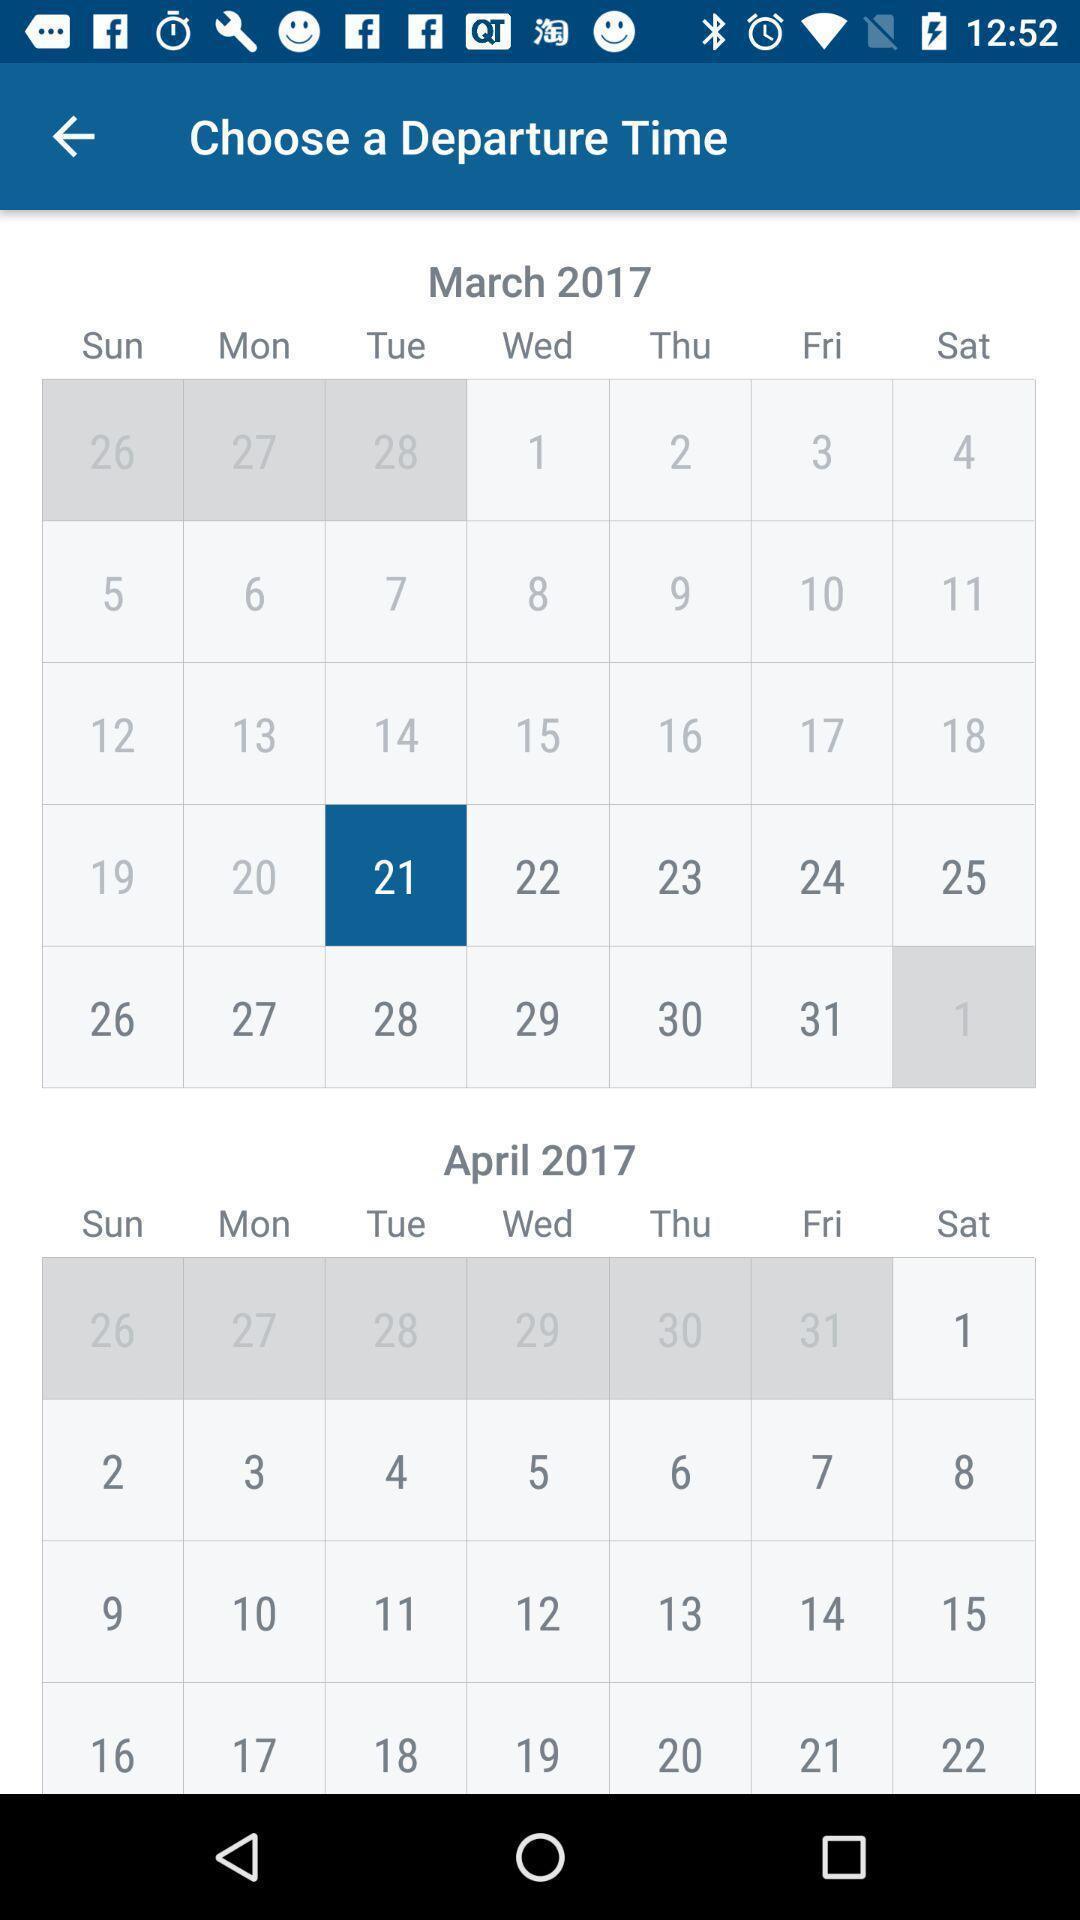Provide a description of this screenshot. Page showing to choose a departure date. 